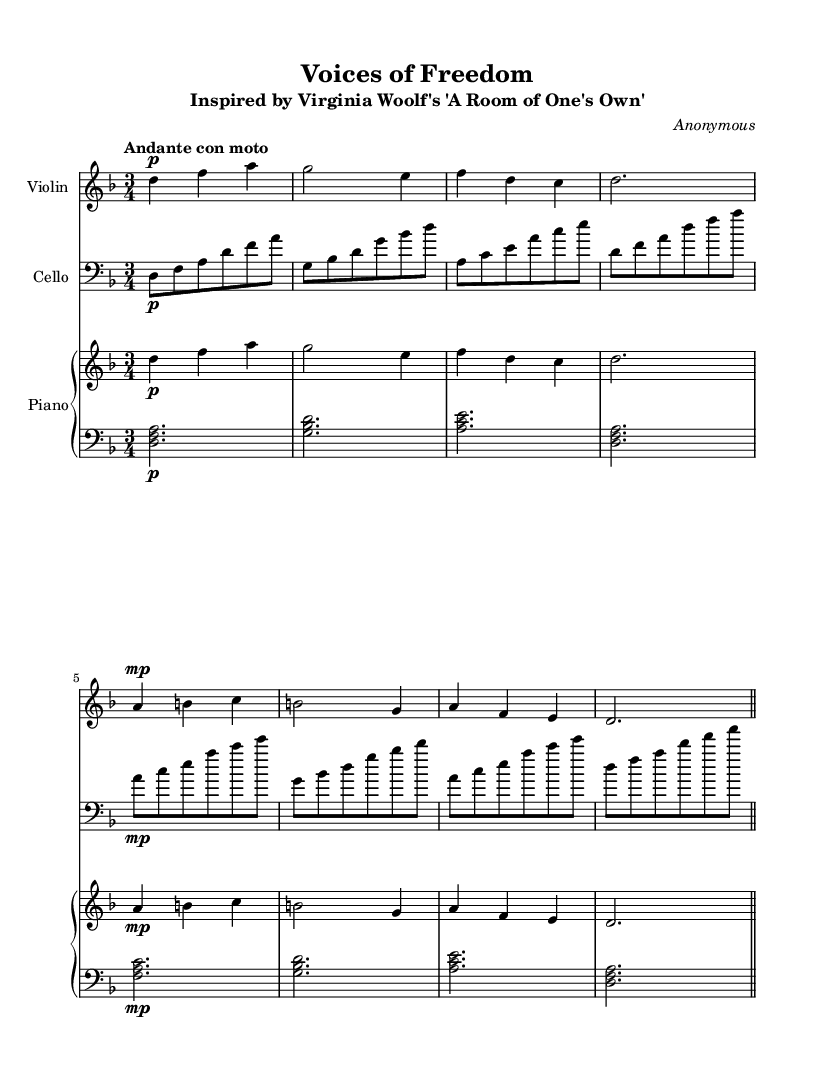What is the key signature of this music? The key signature is indicated by the sharp or flat signs at the beginning of the staff. In this composition, there is one flat, which corresponds to the key of D minor.
Answer: D minor What is the time signature of this piece? The time signature is displayed right after the key signature and is represented by two numbers. In this sheet music, the time signature is 3/4, indicating three beats per measure.
Answer: 3/4 What is the tempo marking for this piece? The tempo marking is specified at the beginning of the score and indicates how fast the music should be played. This piece has the tempo marking "Andante con moto," which suggests a moderately slow and flowing pace.
Answer: Andante con moto How many measures are in the violin part? To find the number of measures, count the vertical lines separating the sections of music. In the violin part, there are five measures before it concludes with a double bar line.
Answer: 5 In which section of the arrangement does the cello play the first note? The cello part starts with a note immediately after the global instructions, indicating that it begins playing in the primary theme of the piece. The note is the first D in the corresponding measure.
Answer: Primary theme What dynamics are indicated for the cello in the first measure? Dynamics are notated with symbols such as "p" for piano (soft) and "mp" for mezzo-piano (medium soft). The first measure for the cello shows a "p," indicating that the section should be played softly.
Answer: Piano What instruments are part of this composition? The instruments are listed in the score at the beginning under each staff. This composition features violin, cello, and piano as the three main instruments.
Answer: Violin, Cello, Piano 